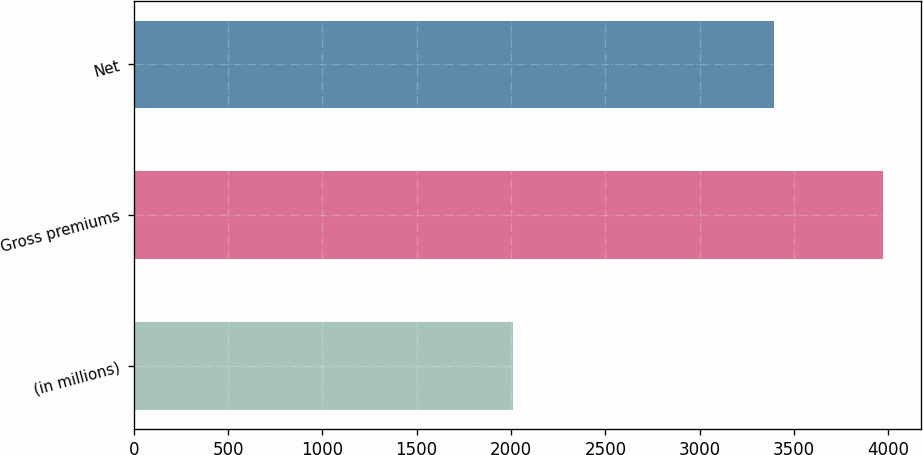Convert chart to OTSL. <chart><loc_0><loc_0><loc_500><loc_500><bar_chart><fcel>(in millions)<fcel>Gross premiums<fcel>Net<nl><fcel>2012<fcel>3974<fcel>3393<nl></chart> 